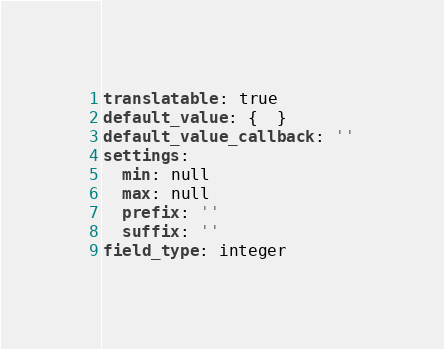Convert code to text. <code><loc_0><loc_0><loc_500><loc_500><_YAML_>translatable: true
default_value: {  }
default_value_callback: ''
settings:
  min: null
  max: null
  prefix: ''
  suffix: ''
field_type: integer
</code> 